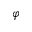Convert formula to latex. <formula><loc_0><loc_0><loc_500><loc_500>\varphi</formula> 